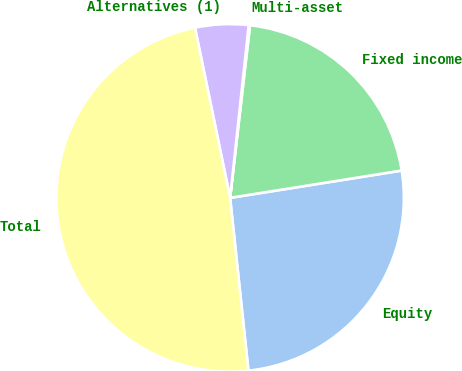Convert chart to OTSL. <chart><loc_0><loc_0><loc_500><loc_500><pie_chart><fcel>Equity<fcel>Fixed income<fcel>Multi-asset<fcel>Alternatives (1)<fcel>Total<nl><fcel>25.83%<fcel>20.66%<fcel>0.12%<fcel>4.95%<fcel>48.44%<nl></chart> 